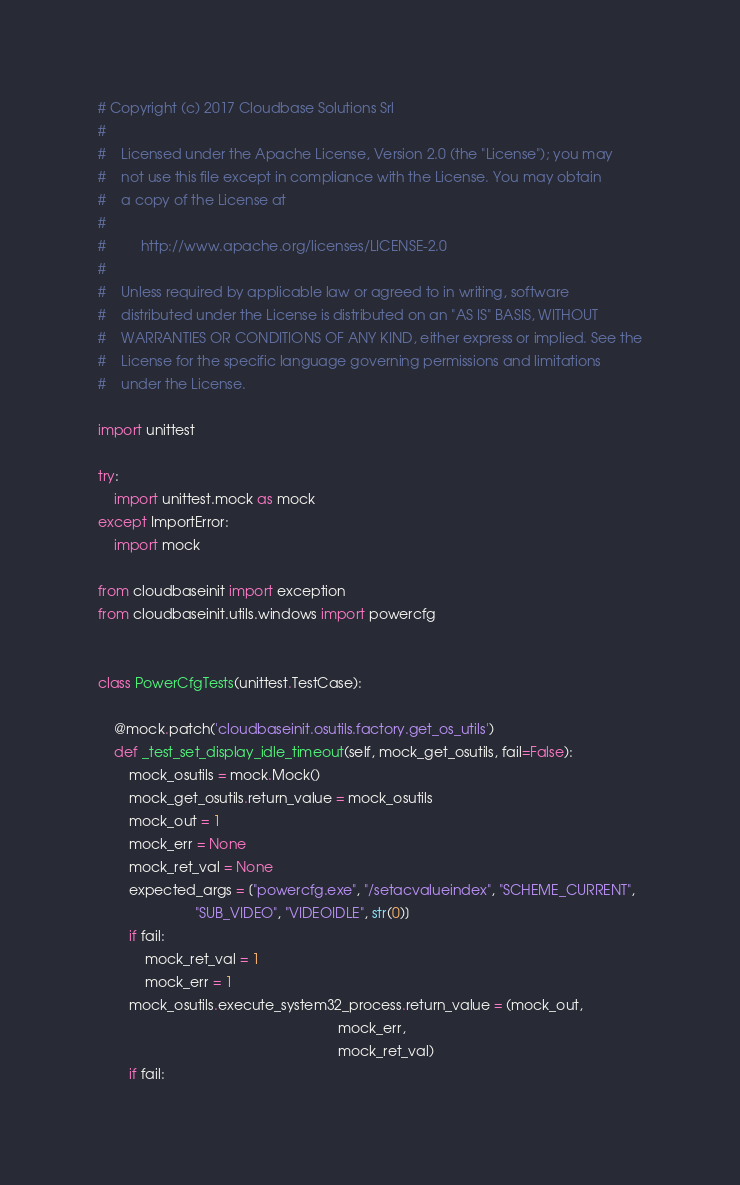Convert code to text. <code><loc_0><loc_0><loc_500><loc_500><_Python_># Copyright (c) 2017 Cloudbase Solutions Srl
#
#    Licensed under the Apache License, Version 2.0 (the "License"); you may
#    not use this file except in compliance with the License. You may obtain
#    a copy of the License at
#
#         http://www.apache.org/licenses/LICENSE-2.0
#
#    Unless required by applicable law or agreed to in writing, software
#    distributed under the License is distributed on an "AS IS" BASIS, WITHOUT
#    WARRANTIES OR CONDITIONS OF ANY KIND, either express or implied. See the
#    License for the specific language governing permissions and limitations
#    under the License.

import unittest

try:
    import unittest.mock as mock
except ImportError:
    import mock

from cloudbaseinit import exception
from cloudbaseinit.utils.windows import powercfg


class PowerCfgTests(unittest.TestCase):

    @mock.patch('cloudbaseinit.osutils.factory.get_os_utils')
    def _test_set_display_idle_timeout(self, mock_get_osutils, fail=False):
        mock_osutils = mock.Mock()
        mock_get_osutils.return_value = mock_osutils
        mock_out = 1
        mock_err = None
        mock_ret_val = None
        expected_args = ["powercfg.exe", "/setacvalueindex", "SCHEME_CURRENT",
                         "SUB_VIDEO", "VIDEOIDLE", str(0)]
        if fail:
            mock_ret_val = 1
            mock_err = 1
        mock_osutils.execute_system32_process.return_value = (mock_out,
                                                              mock_err,
                                                              mock_ret_val)
        if fail:</code> 